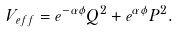<formula> <loc_0><loc_0><loc_500><loc_500>V _ { e f f } = e ^ { - \alpha \phi } Q ^ { 2 } + e ^ { \alpha \phi } P ^ { 2 } .</formula> 